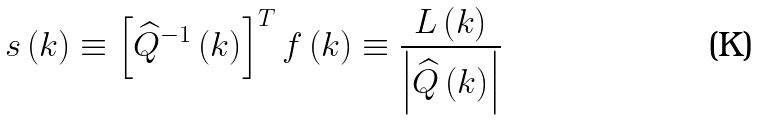<formula> <loc_0><loc_0><loc_500><loc_500>s \left ( k \right ) \equiv \left [ \widehat { Q } ^ { - 1 } \left ( k \right ) \right ] ^ { T } f \left ( k \right ) \equiv \frac { { L } \left ( k \right ) } { \left | \widehat { Q } \left ( k \right ) \right | }</formula> 